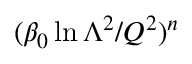<formula> <loc_0><loc_0><loc_500><loc_500>( \beta _ { 0 } \ln \Lambda ^ { 2 } / Q ^ { 2 } ) ^ { n }</formula> 